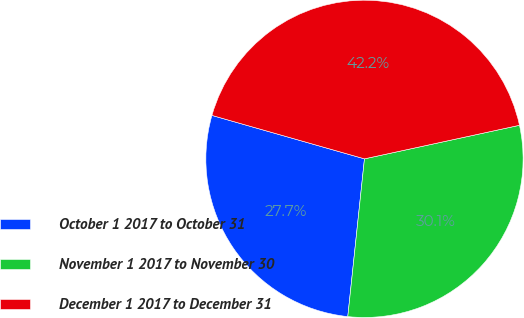Convert chart. <chart><loc_0><loc_0><loc_500><loc_500><pie_chart><fcel>October 1 2017 to October 31<fcel>November 1 2017 to November 30<fcel>December 1 2017 to December 31<nl><fcel>27.74%<fcel>30.07%<fcel>42.19%<nl></chart> 